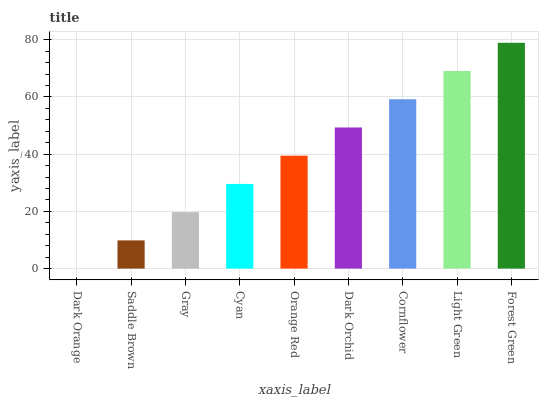Is Saddle Brown the minimum?
Answer yes or no. No. Is Saddle Brown the maximum?
Answer yes or no. No. Is Saddle Brown greater than Dark Orange?
Answer yes or no. Yes. Is Dark Orange less than Saddle Brown?
Answer yes or no. Yes. Is Dark Orange greater than Saddle Brown?
Answer yes or no. No. Is Saddle Brown less than Dark Orange?
Answer yes or no. No. Is Orange Red the high median?
Answer yes or no. Yes. Is Orange Red the low median?
Answer yes or no. Yes. Is Forest Green the high median?
Answer yes or no. No. Is Cyan the low median?
Answer yes or no. No. 